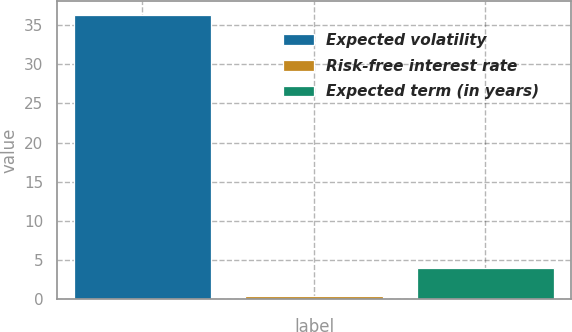<chart> <loc_0><loc_0><loc_500><loc_500><bar_chart><fcel>Expected volatility<fcel>Risk-free interest rate<fcel>Expected term (in years)<nl><fcel>36.3<fcel>0.42<fcel>4.01<nl></chart> 